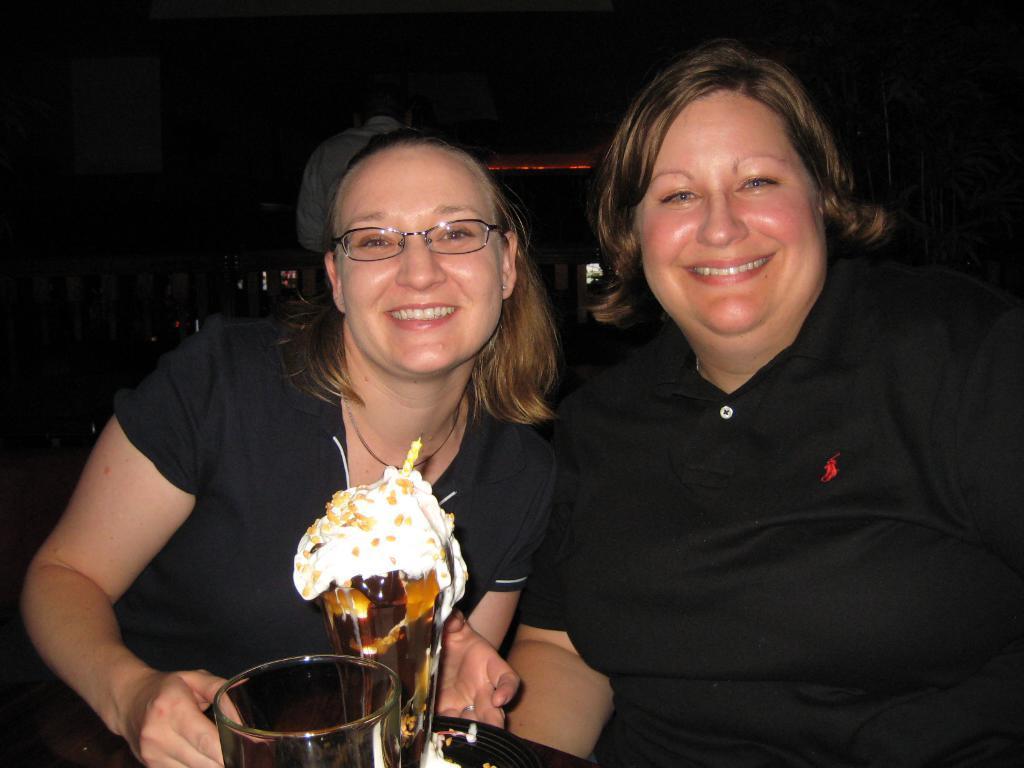Please provide a concise description of this image. In this picture we can see two women, they both are smiling, in front of them we can find glasses and we can see dark background. 